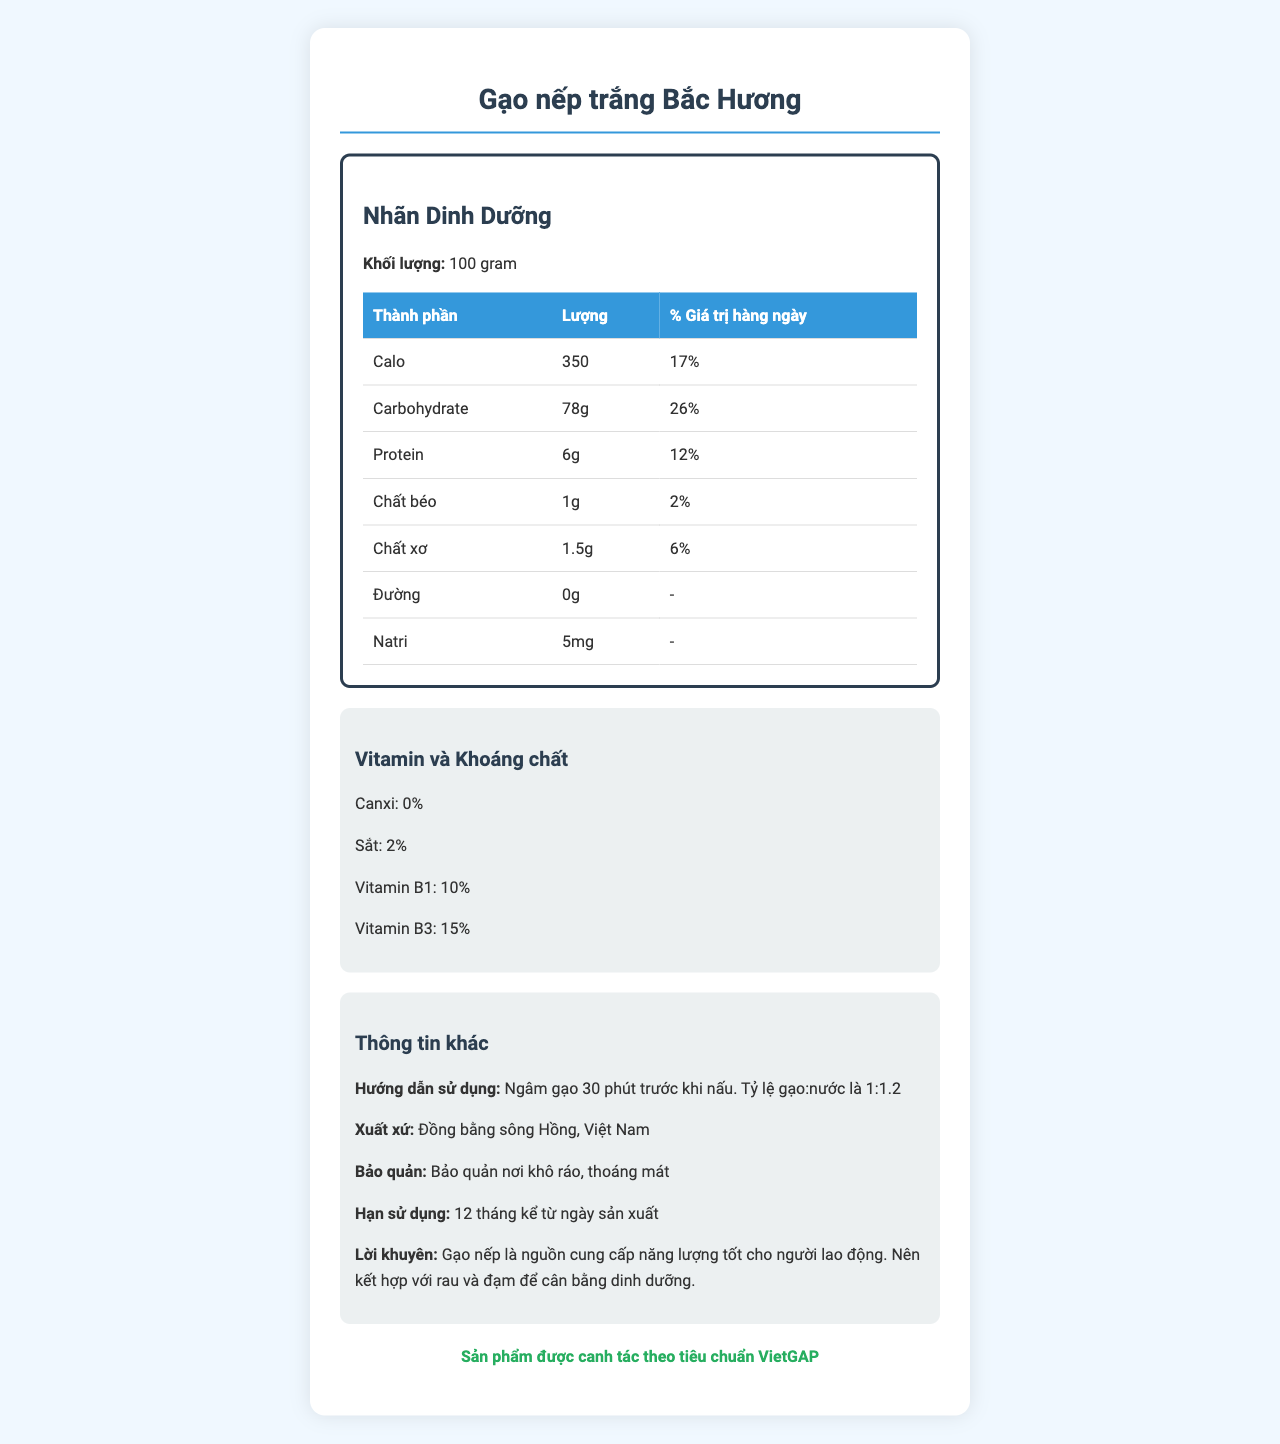what is the total number of calories per 100 grams of the product? The document specifies that there are 350 calories per 100 grams of "Gạo nếp trắng Bắc Hương".
Answer: 350 how much protein does 100 grams of the product contain? The nutrition facts indicate that there are 6 grams of protein per 100 grams of the product.
Answer: 6 grams what percentage of the daily value does carbohydrate contribute? The document states that carbohydrates contribute 26% to the daily value.
Answer: 26% which vitamins are present in the product? The "Vitamin và Khoáng chất" section lists Vitamin B1 and Vitamin B3 as present in the product.
Answer: Vitamin B1 and Vitamin B3 what are the detailed instructions for cooking the product? The "Hướng Dẫn Sử Dụng" section provides specific cooking instructions: "Ngâm gạo 30 phút trước khi nấu. Tỷ lệ gạo:nước là 1:1.2".
Answer: Ngâm gạo 30 phút trước khi nấu. Tỷ lệ gạo:nước là 1:1.2 what is the sodium content per 100 grams? The nutrition label lists 5mg of sodium per 100 grams.
Answer: 5mg What region does the product originate from? The document mentions that the product originates from "Đồng bằng sông Hồng, Việt Nam".
Answer: Đồng bằng sông Hồng, Việt Nam Among the following, which nutrient is present in the smallest amount in the product? A. Protein B. Chất béo C. Calo D. Carbohydrate According to the nutritional information, Chất béo (fat) is present in the smallest amount at 1 gram per 100 grams.
Answer: B. Chất béo Which of the following nutrients has a recommended daily value percentage of 12%? A. Calo B. Carbohydrate C. Protein D. Chất xơ The document indicates that Protein contributes 12% of the daily value.
Answer: C. Protein Does the product contain any sugar? The "Nutrition Facts" section specifies that the product contains 0 grams of sugar.
Answer: No Summarize the main nutritional characteristics and guidelines for the product. The document details the nutritional breakdown, usage instructions, origin, storage, and additional advice on how the product is a good energy source, best combined with vegetables and protein.
Answer: The product "Gạo nếp trắng Bắc Hương" provides 350 calories, 78 grams of carbohydrates, 6 grams of protein, and minimal fat and sodium per 100 grams. It includes essential vitamins B1 and B3 and is recommended for soaking before cooking. How much iron is present in the product in any form? The document only indicates that iron is present at 2% of the daily value but does not specify the exact amount in milligrams or grams.
Answer: Not enough information What is the % daily value for fiber content? The fiber content contributes 6% to the daily value according to the "Nutrition Facts" section.
Answer: 6% Is the product certified under any agricultural standard? The product is labeled as being cultivated according to the VietGAP standard.
Answer: Yes What is the shelf life of the product from the manufacturing date? The document states the shelf life as "12 tháng kể từ ngày sản xuất".
Answer: 12 months How should the product be stored? The storage recommendation is to keep it in a dry and cool place.
Answer: Bảo quản nơi khô ráo, thoáng mát 